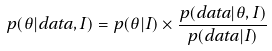<formula> <loc_0><loc_0><loc_500><loc_500>p ( \theta | d a t a , I ) = p ( \theta | I ) \times \frac { p ( d a t a | \theta , I ) } { p ( d a t a | I ) }</formula> 